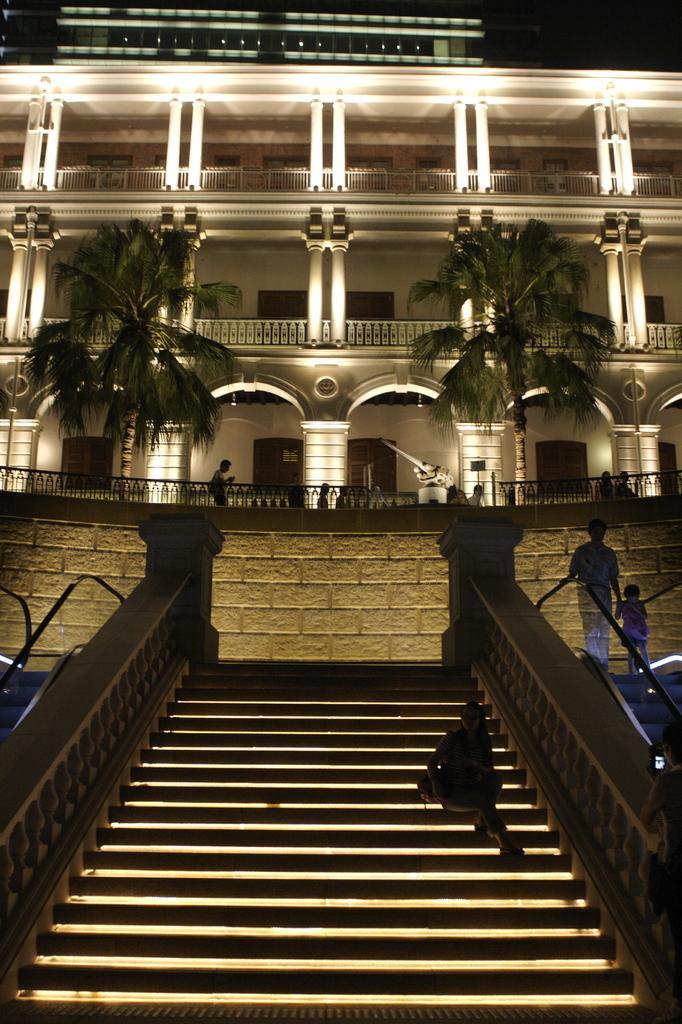Please provide a concise description of this image. In this picture there is a building and there are trees. In the foreground there is a staircase and there are escalators and there are two persons standing on the escalators and there is a person sitting on the stair case. At the back there are group of people behind the railing and there are lights on the building. At the top there is sky. 